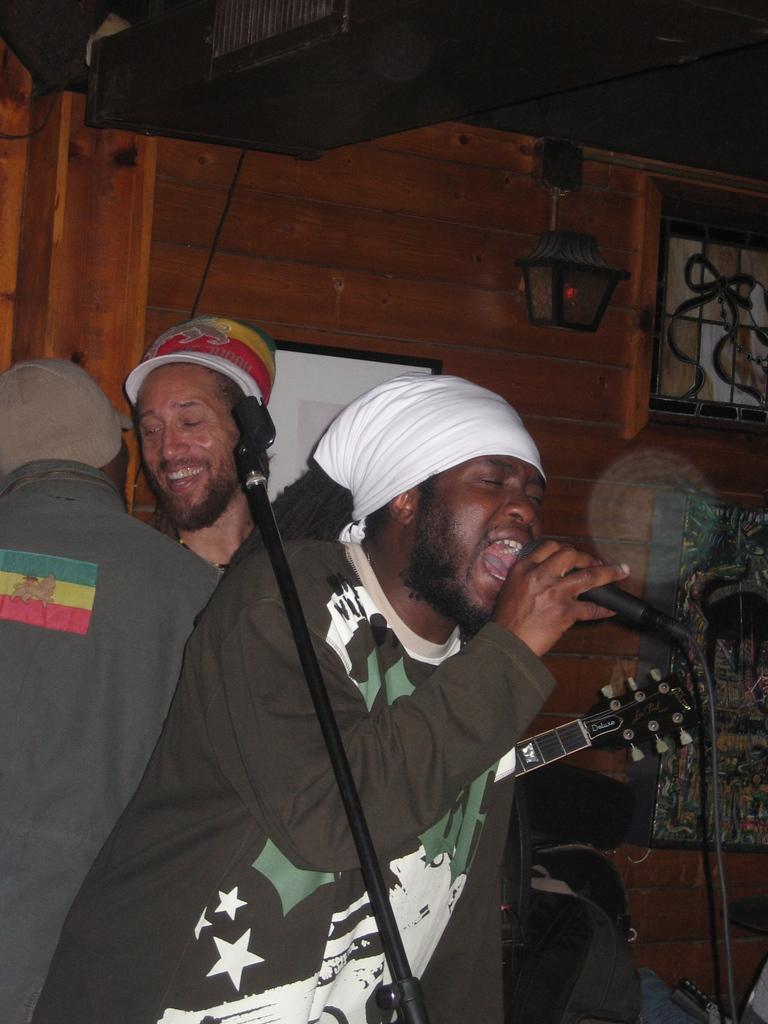How would you summarize this image in a sentence or two? In this image there are three people, one person is standing and singing and he is holding microphone and the other person is smiling. At the back there's a light. 